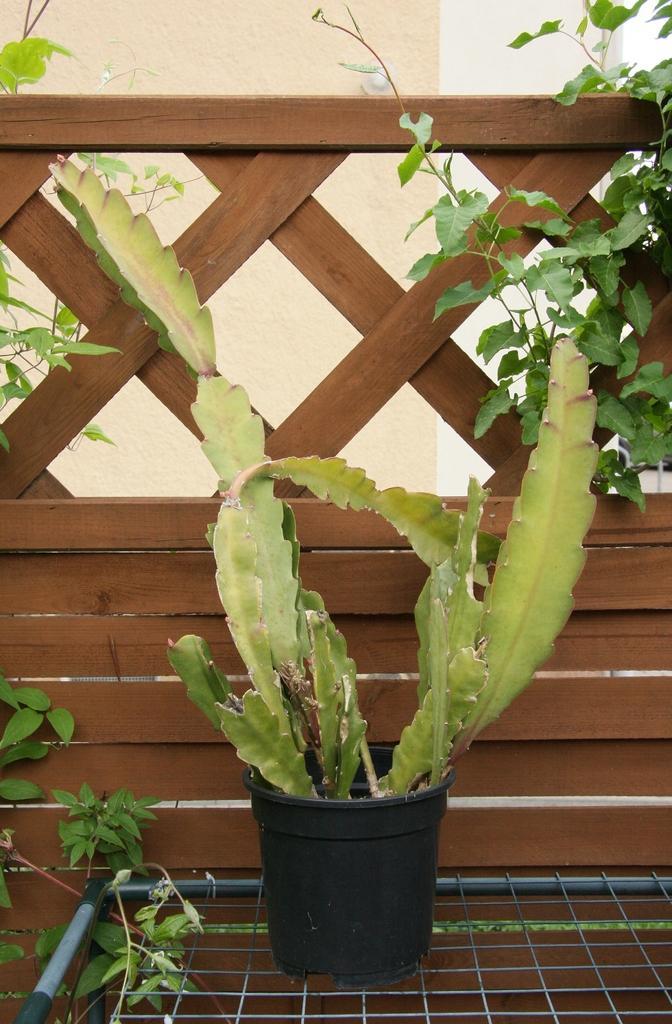How would you summarize this image in a sentence or two? In the picture I can see the plant pot on the metal grill which is at the bottom of the picture. I can see the wooden fence and green leaves. In the background, I can see the wall. 